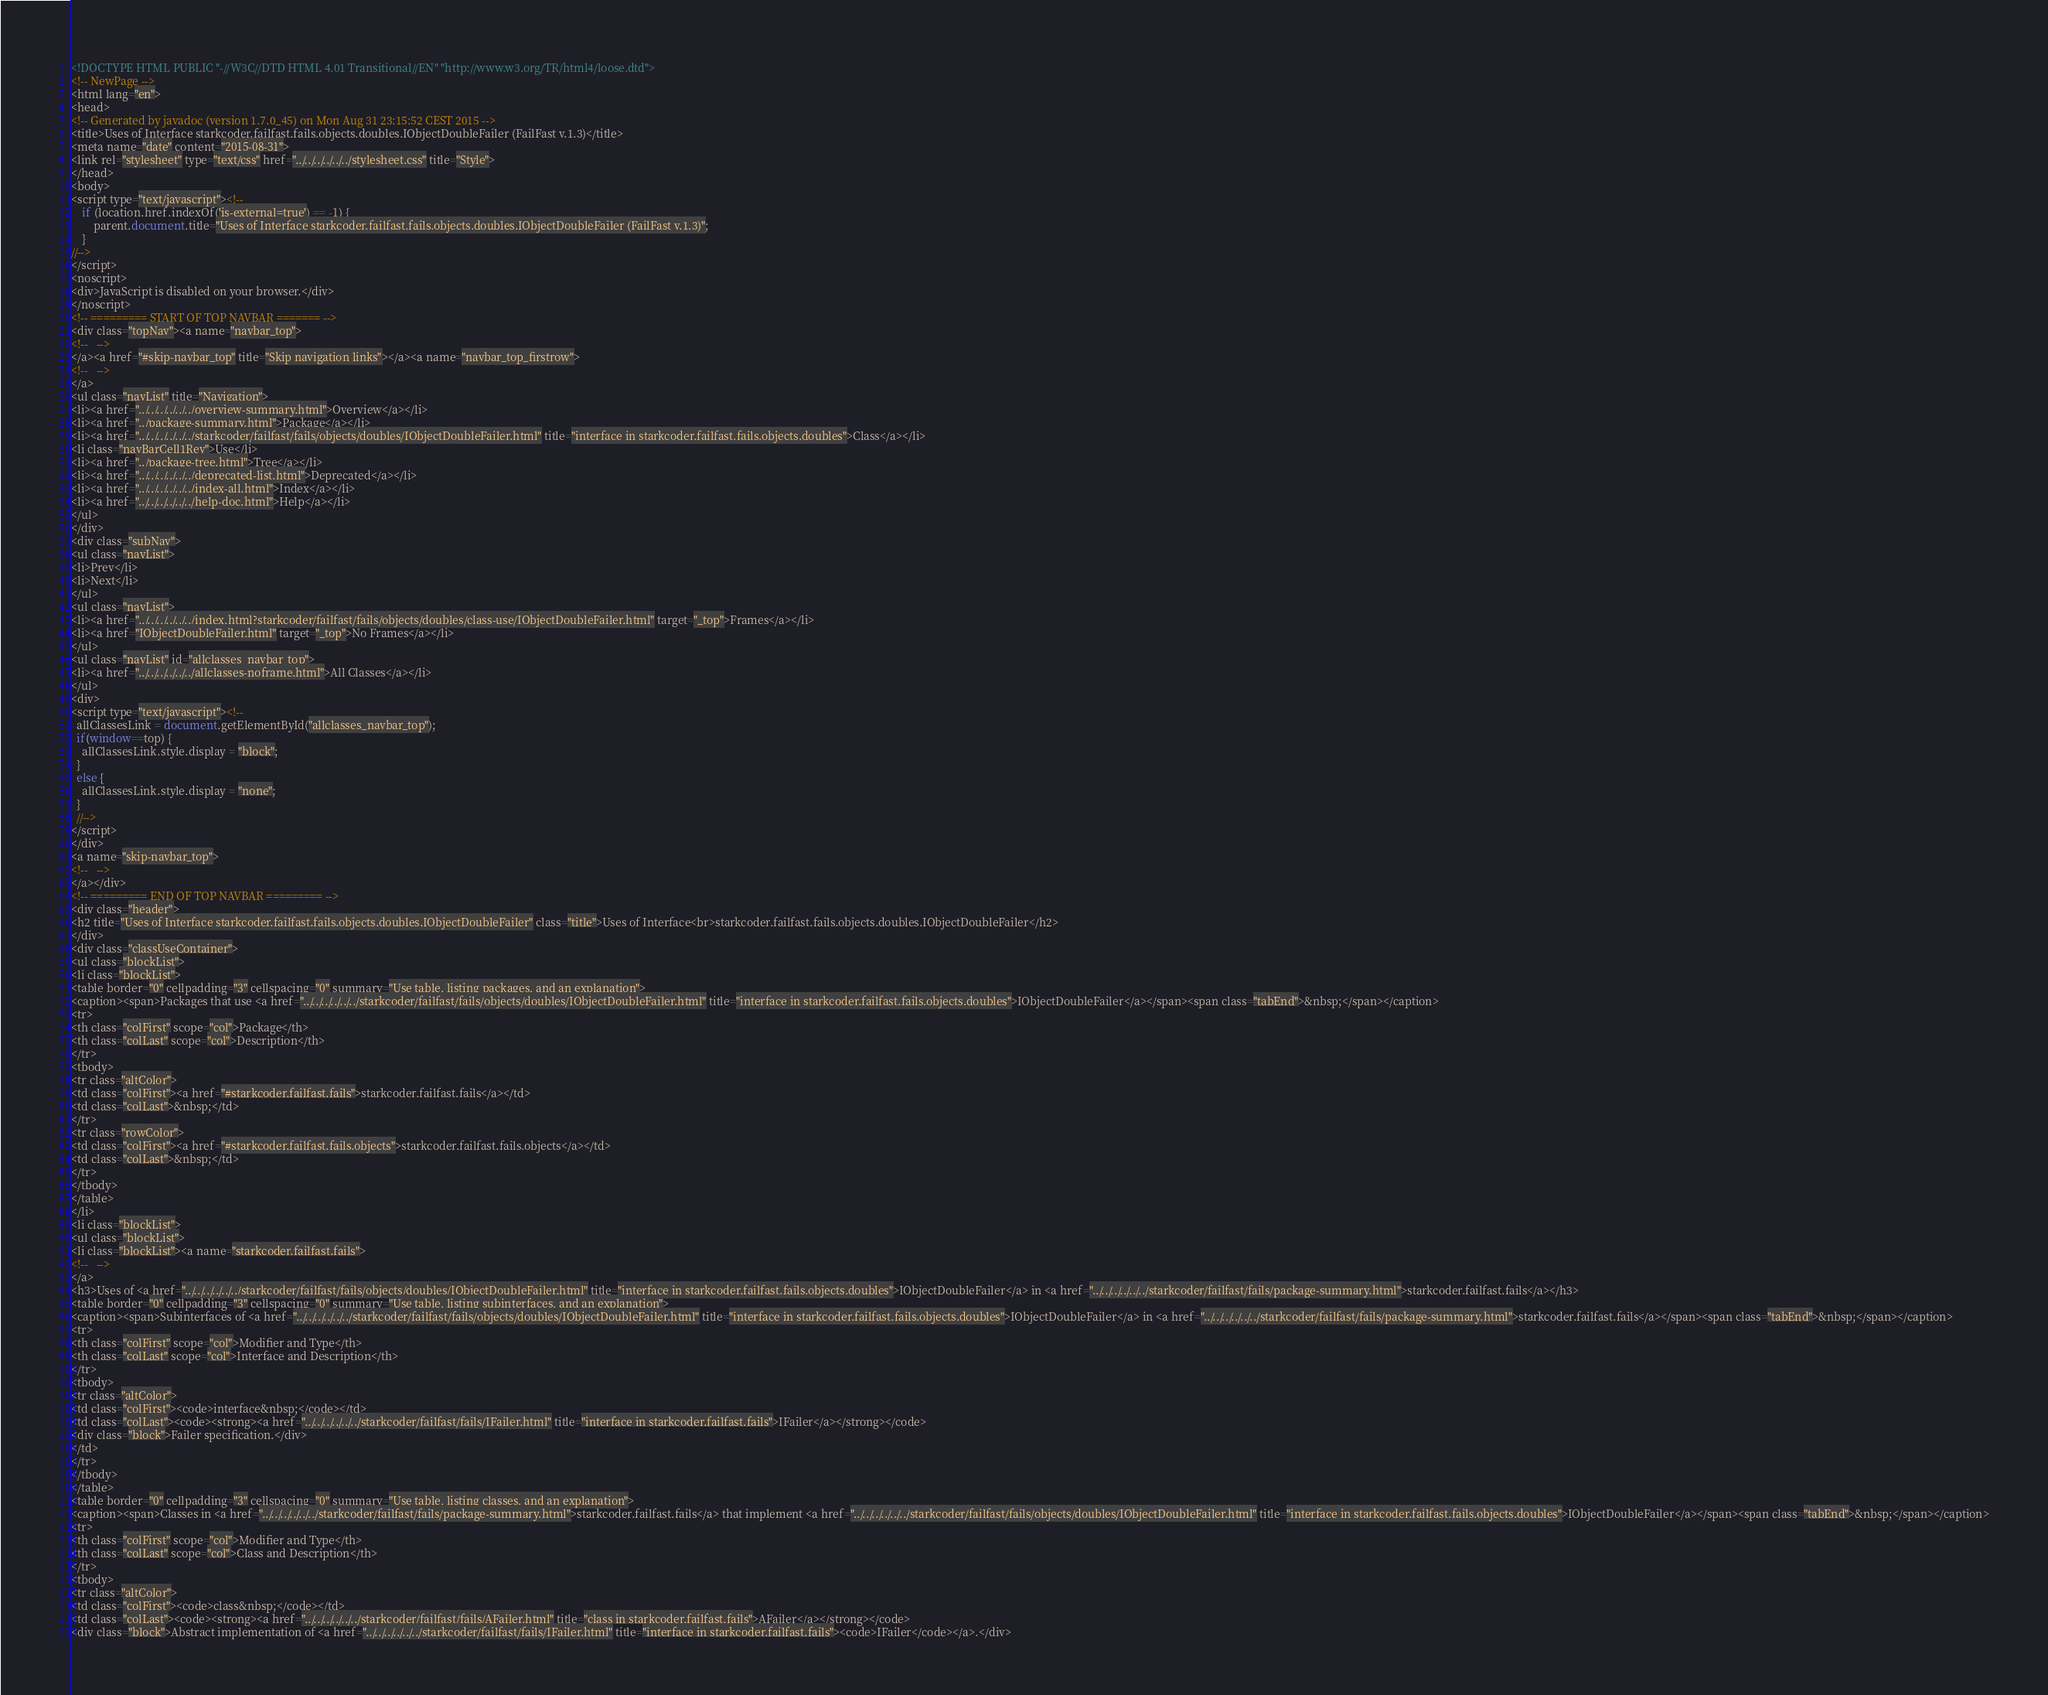Convert code to text. <code><loc_0><loc_0><loc_500><loc_500><_HTML_><!DOCTYPE HTML PUBLIC "-//W3C//DTD HTML 4.01 Transitional//EN" "http://www.w3.org/TR/html4/loose.dtd">
<!-- NewPage -->
<html lang="en">
<head>
<!-- Generated by javadoc (version 1.7.0_45) on Mon Aug 31 23:15:52 CEST 2015 -->
<title>Uses of Interface starkcoder.failfast.fails.objects.doubles.IObjectDoubleFailer (FailFast v.1.3)</title>
<meta name="date" content="2015-08-31">
<link rel="stylesheet" type="text/css" href="../../../../../../stylesheet.css" title="Style">
</head>
<body>
<script type="text/javascript"><!--
    if (location.href.indexOf('is-external=true') == -1) {
        parent.document.title="Uses of Interface starkcoder.failfast.fails.objects.doubles.IObjectDoubleFailer (FailFast v.1.3)";
    }
//-->
</script>
<noscript>
<div>JavaScript is disabled on your browser.</div>
</noscript>
<!-- ========= START OF TOP NAVBAR ======= -->
<div class="topNav"><a name="navbar_top">
<!--   -->
</a><a href="#skip-navbar_top" title="Skip navigation links"></a><a name="navbar_top_firstrow">
<!--   -->
</a>
<ul class="navList" title="Navigation">
<li><a href="../../../../../../overview-summary.html">Overview</a></li>
<li><a href="../package-summary.html">Package</a></li>
<li><a href="../../../../../../starkcoder/failfast/fails/objects/doubles/IObjectDoubleFailer.html" title="interface in starkcoder.failfast.fails.objects.doubles">Class</a></li>
<li class="navBarCell1Rev">Use</li>
<li><a href="../package-tree.html">Tree</a></li>
<li><a href="../../../../../../deprecated-list.html">Deprecated</a></li>
<li><a href="../../../../../../index-all.html">Index</a></li>
<li><a href="../../../../../../help-doc.html">Help</a></li>
</ul>
</div>
<div class="subNav">
<ul class="navList">
<li>Prev</li>
<li>Next</li>
</ul>
<ul class="navList">
<li><a href="../../../../../../index.html?starkcoder/failfast/fails/objects/doubles/class-use/IObjectDoubleFailer.html" target="_top">Frames</a></li>
<li><a href="IObjectDoubleFailer.html" target="_top">No Frames</a></li>
</ul>
<ul class="navList" id="allclasses_navbar_top">
<li><a href="../../../../../../allclasses-noframe.html">All Classes</a></li>
</ul>
<div>
<script type="text/javascript"><!--
  allClassesLink = document.getElementById("allclasses_navbar_top");
  if(window==top) {
    allClassesLink.style.display = "block";
  }
  else {
    allClassesLink.style.display = "none";
  }
  //-->
</script>
</div>
<a name="skip-navbar_top">
<!--   -->
</a></div>
<!-- ========= END OF TOP NAVBAR ========= -->
<div class="header">
<h2 title="Uses of Interface starkcoder.failfast.fails.objects.doubles.IObjectDoubleFailer" class="title">Uses of Interface<br>starkcoder.failfast.fails.objects.doubles.IObjectDoubleFailer</h2>
</div>
<div class="classUseContainer">
<ul class="blockList">
<li class="blockList">
<table border="0" cellpadding="3" cellspacing="0" summary="Use table, listing packages, and an explanation">
<caption><span>Packages that use <a href="../../../../../../starkcoder/failfast/fails/objects/doubles/IObjectDoubleFailer.html" title="interface in starkcoder.failfast.fails.objects.doubles">IObjectDoubleFailer</a></span><span class="tabEnd">&nbsp;</span></caption>
<tr>
<th class="colFirst" scope="col">Package</th>
<th class="colLast" scope="col">Description</th>
</tr>
<tbody>
<tr class="altColor">
<td class="colFirst"><a href="#starkcoder.failfast.fails">starkcoder.failfast.fails</a></td>
<td class="colLast">&nbsp;</td>
</tr>
<tr class="rowColor">
<td class="colFirst"><a href="#starkcoder.failfast.fails.objects">starkcoder.failfast.fails.objects</a></td>
<td class="colLast">&nbsp;</td>
</tr>
</tbody>
</table>
</li>
<li class="blockList">
<ul class="blockList">
<li class="blockList"><a name="starkcoder.failfast.fails">
<!--   -->
</a>
<h3>Uses of <a href="../../../../../../starkcoder/failfast/fails/objects/doubles/IObjectDoubleFailer.html" title="interface in starkcoder.failfast.fails.objects.doubles">IObjectDoubleFailer</a> in <a href="../../../../../../starkcoder/failfast/fails/package-summary.html">starkcoder.failfast.fails</a></h3>
<table border="0" cellpadding="3" cellspacing="0" summary="Use table, listing subinterfaces, and an explanation">
<caption><span>Subinterfaces of <a href="../../../../../../starkcoder/failfast/fails/objects/doubles/IObjectDoubleFailer.html" title="interface in starkcoder.failfast.fails.objects.doubles">IObjectDoubleFailer</a> in <a href="../../../../../../starkcoder/failfast/fails/package-summary.html">starkcoder.failfast.fails</a></span><span class="tabEnd">&nbsp;</span></caption>
<tr>
<th class="colFirst" scope="col">Modifier and Type</th>
<th class="colLast" scope="col">Interface and Description</th>
</tr>
<tbody>
<tr class="altColor">
<td class="colFirst"><code>interface&nbsp;</code></td>
<td class="colLast"><code><strong><a href="../../../../../../starkcoder/failfast/fails/IFailer.html" title="interface in starkcoder.failfast.fails">IFailer</a></strong></code>
<div class="block">Failer specification.</div>
</td>
</tr>
</tbody>
</table>
<table border="0" cellpadding="3" cellspacing="0" summary="Use table, listing classes, and an explanation">
<caption><span>Classes in <a href="../../../../../../starkcoder/failfast/fails/package-summary.html">starkcoder.failfast.fails</a> that implement <a href="../../../../../../starkcoder/failfast/fails/objects/doubles/IObjectDoubleFailer.html" title="interface in starkcoder.failfast.fails.objects.doubles">IObjectDoubleFailer</a></span><span class="tabEnd">&nbsp;</span></caption>
<tr>
<th class="colFirst" scope="col">Modifier and Type</th>
<th class="colLast" scope="col">Class and Description</th>
</tr>
<tbody>
<tr class="altColor">
<td class="colFirst"><code>class&nbsp;</code></td>
<td class="colLast"><code><strong><a href="../../../../../../starkcoder/failfast/fails/AFailer.html" title="class in starkcoder.failfast.fails">AFailer</a></strong></code>
<div class="block">Abstract implementation of <a href="../../../../../../starkcoder/failfast/fails/IFailer.html" title="interface in starkcoder.failfast.fails"><code>IFailer</code></a>.</div></code> 